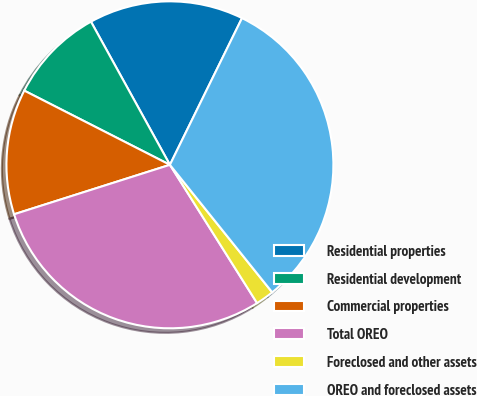Convert chart. <chart><loc_0><loc_0><loc_500><loc_500><pie_chart><fcel>Residential properties<fcel>Residential development<fcel>Commercial properties<fcel>Total OREO<fcel>Foreclosed and other assets<fcel>OREO and foreclosed assets<nl><fcel>15.29%<fcel>9.48%<fcel>12.39%<fcel>29.06%<fcel>1.81%<fcel>31.97%<nl></chart> 